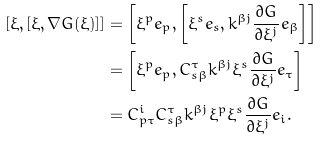Convert formula to latex. <formula><loc_0><loc_0><loc_500><loc_500>[ \xi , [ \xi , \nabla G ( \xi ) ] ] & = \left [ \xi ^ { p } { e } _ { p } , \left [ \xi ^ { s } { e } _ { s } , k ^ { \beta j } \frac { \partial G } { \partial \xi ^ { j } } { e } _ { \beta } \right ] \right ] \\ & = \left [ \xi ^ { p } { e } _ { p } , C _ { s \beta } ^ { \tau } k ^ { \beta j } \xi ^ { s } \frac { \partial G } { \partial \xi ^ { j } } { e } _ { \tau } \right ] \\ & = C _ { p \tau } ^ { i } C _ { s \beta } ^ { \tau } k ^ { \beta j } \xi ^ { p } \xi ^ { s } \frac { \partial G } { \partial \xi ^ { j } } { e } _ { i } .</formula> 